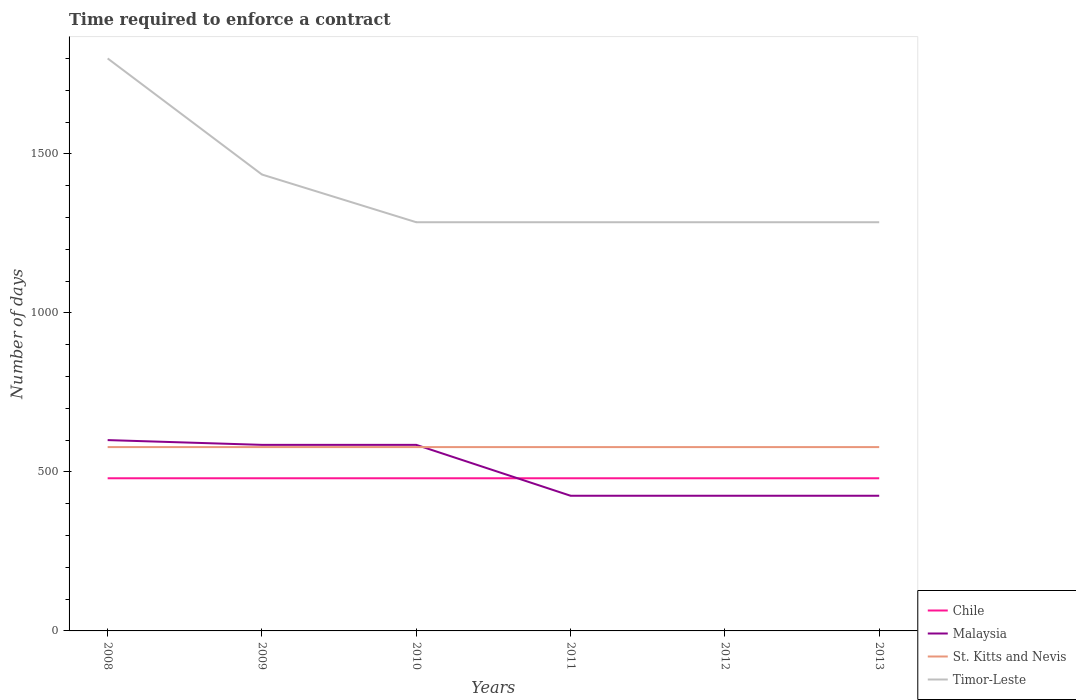How many different coloured lines are there?
Your response must be concise. 4. Does the line corresponding to Chile intersect with the line corresponding to Timor-Leste?
Offer a very short reply. No. Is the number of lines equal to the number of legend labels?
Make the answer very short. Yes. Across all years, what is the maximum number of days required to enforce a contract in Timor-Leste?
Provide a short and direct response. 1285. What is the difference between the highest and the second highest number of days required to enforce a contract in St. Kitts and Nevis?
Offer a very short reply. 0. Is the number of days required to enforce a contract in Malaysia strictly greater than the number of days required to enforce a contract in Timor-Leste over the years?
Provide a short and direct response. Yes. How many years are there in the graph?
Provide a short and direct response. 6. What is the difference between two consecutive major ticks on the Y-axis?
Make the answer very short. 500. Are the values on the major ticks of Y-axis written in scientific E-notation?
Your answer should be compact. No. Does the graph contain grids?
Your answer should be compact. No. How many legend labels are there?
Provide a succinct answer. 4. What is the title of the graph?
Your response must be concise. Time required to enforce a contract. What is the label or title of the Y-axis?
Give a very brief answer. Number of days. What is the Number of days of Chile in 2008?
Provide a short and direct response. 480. What is the Number of days in Malaysia in 2008?
Keep it short and to the point. 600. What is the Number of days in St. Kitts and Nevis in 2008?
Your answer should be very brief. 578. What is the Number of days of Timor-Leste in 2008?
Your response must be concise. 1800. What is the Number of days of Chile in 2009?
Make the answer very short. 480. What is the Number of days in Malaysia in 2009?
Keep it short and to the point. 585. What is the Number of days in St. Kitts and Nevis in 2009?
Make the answer very short. 578. What is the Number of days in Timor-Leste in 2009?
Your answer should be compact. 1435. What is the Number of days in Chile in 2010?
Offer a very short reply. 480. What is the Number of days in Malaysia in 2010?
Provide a succinct answer. 585. What is the Number of days of St. Kitts and Nevis in 2010?
Your answer should be very brief. 578. What is the Number of days in Timor-Leste in 2010?
Keep it short and to the point. 1285. What is the Number of days of Chile in 2011?
Provide a short and direct response. 480. What is the Number of days of Malaysia in 2011?
Ensure brevity in your answer.  425. What is the Number of days in St. Kitts and Nevis in 2011?
Keep it short and to the point. 578. What is the Number of days of Timor-Leste in 2011?
Provide a short and direct response. 1285. What is the Number of days of Chile in 2012?
Ensure brevity in your answer.  480. What is the Number of days in Malaysia in 2012?
Your answer should be very brief. 425. What is the Number of days of St. Kitts and Nevis in 2012?
Keep it short and to the point. 578. What is the Number of days in Timor-Leste in 2012?
Give a very brief answer. 1285. What is the Number of days of Chile in 2013?
Keep it short and to the point. 480. What is the Number of days of Malaysia in 2013?
Provide a succinct answer. 425. What is the Number of days in St. Kitts and Nevis in 2013?
Your answer should be compact. 578. What is the Number of days in Timor-Leste in 2013?
Offer a terse response. 1285. Across all years, what is the maximum Number of days in Chile?
Your response must be concise. 480. Across all years, what is the maximum Number of days of Malaysia?
Keep it short and to the point. 600. Across all years, what is the maximum Number of days in St. Kitts and Nevis?
Keep it short and to the point. 578. Across all years, what is the maximum Number of days in Timor-Leste?
Provide a succinct answer. 1800. Across all years, what is the minimum Number of days in Chile?
Offer a terse response. 480. Across all years, what is the minimum Number of days of Malaysia?
Ensure brevity in your answer.  425. Across all years, what is the minimum Number of days in St. Kitts and Nevis?
Your answer should be compact. 578. Across all years, what is the minimum Number of days in Timor-Leste?
Keep it short and to the point. 1285. What is the total Number of days in Chile in the graph?
Offer a terse response. 2880. What is the total Number of days of Malaysia in the graph?
Your answer should be compact. 3045. What is the total Number of days of St. Kitts and Nevis in the graph?
Offer a terse response. 3468. What is the total Number of days in Timor-Leste in the graph?
Make the answer very short. 8375. What is the difference between the Number of days in St. Kitts and Nevis in 2008 and that in 2009?
Offer a very short reply. 0. What is the difference between the Number of days in Timor-Leste in 2008 and that in 2009?
Keep it short and to the point. 365. What is the difference between the Number of days in Chile in 2008 and that in 2010?
Ensure brevity in your answer.  0. What is the difference between the Number of days in Timor-Leste in 2008 and that in 2010?
Provide a short and direct response. 515. What is the difference between the Number of days of Malaysia in 2008 and that in 2011?
Provide a short and direct response. 175. What is the difference between the Number of days of Timor-Leste in 2008 and that in 2011?
Make the answer very short. 515. What is the difference between the Number of days of Chile in 2008 and that in 2012?
Give a very brief answer. 0. What is the difference between the Number of days of Malaysia in 2008 and that in 2012?
Give a very brief answer. 175. What is the difference between the Number of days in St. Kitts and Nevis in 2008 and that in 2012?
Your answer should be very brief. 0. What is the difference between the Number of days in Timor-Leste in 2008 and that in 2012?
Offer a very short reply. 515. What is the difference between the Number of days of Chile in 2008 and that in 2013?
Ensure brevity in your answer.  0. What is the difference between the Number of days in Malaysia in 2008 and that in 2013?
Your response must be concise. 175. What is the difference between the Number of days of St. Kitts and Nevis in 2008 and that in 2013?
Provide a short and direct response. 0. What is the difference between the Number of days of Timor-Leste in 2008 and that in 2013?
Provide a short and direct response. 515. What is the difference between the Number of days in Malaysia in 2009 and that in 2010?
Your answer should be compact. 0. What is the difference between the Number of days in St. Kitts and Nevis in 2009 and that in 2010?
Make the answer very short. 0. What is the difference between the Number of days of Timor-Leste in 2009 and that in 2010?
Your answer should be compact. 150. What is the difference between the Number of days of Chile in 2009 and that in 2011?
Provide a succinct answer. 0. What is the difference between the Number of days in Malaysia in 2009 and that in 2011?
Make the answer very short. 160. What is the difference between the Number of days in Timor-Leste in 2009 and that in 2011?
Your answer should be very brief. 150. What is the difference between the Number of days in Chile in 2009 and that in 2012?
Offer a very short reply. 0. What is the difference between the Number of days in Malaysia in 2009 and that in 2012?
Make the answer very short. 160. What is the difference between the Number of days in St. Kitts and Nevis in 2009 and that in 2012?
Your answer should be very brief. 0. What is the difference between the Number of days in Timor-Leste in 2009 and that in 2012?
Make the answer very short. 150. What is the difference between the Number of days in Malaysia in 2009 and that in 2013?
Keep it short and to the point. 160. What is the difference between the Number of days in St. Kitts and Nevis in 2009 and that in 2013?
Your answer should be very brief. 0. What is the difference between the Number of days in Timor-Leste in 2009 and that in 2013?
Offer a very short reply. 150. What is the difference between the Number of days in Chile in 2010 and that in 2011?
Offer a terse response. 0. What is the difference between the Number of days of Malaysia in 2010 and that in 2011?
Provide a succinct answer. 160. What is the difference between the Number of days in St. Kitts and Nevis in 2010 and that in 2011?
Make the answer very short. 0. What is the difference between the Number of days in Malaysia in 2010 and that in 2012?
Your response must be concise. 160. What is the difference between the Number of days of Timor-Leste in 2010 and that in 2012?
Make the answer very short. 0. What is the difference between the Number of days of Chile in 2010 and that in 2013?
Ensure brevity in your answer.  0. What is the difference between the Number of days of Malaysia in 2010 and that in 2013?
Keep it short and to the point. 160. What is the difference between the Number of days in St. Kitts and Nevis in 2010 and that in 2013?
Provide a succinct answer. 0. What is the difference between the Number of days in Timor-Leste in 2010 and that in 2013?
Offer a very short reply. 0. What is the difference between the Number of days of Chile in 2011 and that in 2012?
Provide a short and direct response. 0. What is the difference between the Number of days of Chile in 2011 and that in 2013?
Give a very brief answer. 0. What is the difference between the Number of days of Malaysia in 2011 and that in 2013?
Provide a succinct answer. 0. What is the difference between the Number of days of Timor-Leste in 2011 and that in 2013?
Your response must be concise. 0. What is the difference between the Number of days in Chile in 2012 and that in 2013?
Provide a short and direct response. 0. What is the difference between the Number of days of Chile in 2008 and the Number of days of Malaysia in 2009?
Make the answer very short. -105. What is the difference between the Number of days in Chile in 2008 and the Number of days in St. Kitts and Nevis in 2009?
Make the answer very short. -98. What is the difference between the Number of days in Chile in 2008 and the Number of days in Timor-Leste in 2009?
Your response must be concise. -955. What is the difference between the Number of days in Malaysia in 2008 and the Number of days in St. Kitts and Nevis in 2009?
Keep it short and to the point. 22. What is the difference between the Number of days of Malaysia in 2008 and the Number of days of Timor-Leste in 2009?
Your response must be concise. -835. What is the difference between the Number of days in St. Kitts and Nevis in 2008 and the Number of days in Timor-Leste in 2009?
Your answer should be compact. -857. What is the difference between the Number of days of Chile in 2008 and the Number of days of Malaysia in 2010?
Provide a succinct answer. -105. What is the difference between the Number of days in Chile in 2008 and the Number of days in St. Kitts and Nevis in 2010?
Provide a short and direct response. -98. What is the difference between the Number of days in Chile in 2008 and the Number of days in Timor-Leste in 2010?
Provide a short and direct response. -805. What is the difference between the Number of days of Malaysia in 2008 and the Number of days of Timor-Leste in 2010?
Your answer should be compact. -685. What is the difference between the Number of days of St. Kitts and Nevis in 2008 and the Number of days of Timor-Leste in 2010?
Make the answer very short. -707. What is the difference between the Number of days in Chile in 2008 and the Number of days in Malaysia in 2011?
Keep it short and to the point. 55. What is the difference between the Number of days of Chile in 2008 and the Number of days of St. Kitts and Nevis in 2011?
Your answer should be compact. -98. What is the difference between the Number of days of Chile in 2008 and the Number of days of Timor-Leste in 2011?
Ensure brevity in your answer.  -805. What is the difference between the Number of days of Malaysia in 2008 and the Number of days of St. Kitts and Nevis in 2011?
Your answer should be compact. 22. What is the difference between the Number of days in Malaysia in 2008 and the Number of days in Timor-Leste in 2011?
Provide a short and direct response. -685. What is the difference between the Number of days in St. Kitts and Nevis in 2008 and the Number of days in Timor-Leste in 2011?
Your answer should be very brief. -707. What is the difference between the Number of days of Chile in 2008 and the Number of days of St. Kitts and Nevis in 2012?
Provide a succinct answer. -98. What is the difference between the Number of days in Chile in 2008 and the Number of days in Timor-Leste in 2012?
Make the answer very short. -805. What is the difference between the Number of days of Malaysia in 2008 and the Number of days of St. Kitts and Nevis in 2012?
Keep it short and to the point. 22. What is the difference between the Number of days in Malaysia in 2008 and the Number of days in Timor-Leste in 2012?
Keep it short and to the point. -685. What is the difference between the Number of days of St. Kitts and Nevis in 2008 and the Number of days of Timor-Leste in 2012?
Make the answer very short. -707. What is the difference between the Number of days of Chile in 2008 and the Number of days of St. Kitts and Nevis in 2013?
Provide a succinct answer. -98. What is the difference between the Number of days of Chile in 2008 and the Number of days of Timor-Leste in 2013?
Your answer should be compact. -805. What is the difference between the Number of days in Malaysia in 2008 and the Number of days in St. Kitts and Nevis in 2013?
Give a very brief answer. 22. What is the difference between the Number of days of Malaysia in 2008 and the Number of days of Timor-Leste in 2013?
Offer a very short reply. -685. What is the difference between the Number of days of St. Kitts and Nevis in 2008 and the Number of days of Timor-Leste in 2013?
Your answer should be very brief. -707. What is the difference between the Number of days in Chile in 2009 and the Number of days in Malaysia in 2010?
Make the answer very short. -105. What is the difference between the Number of days in Chile in 2009 and the Number of days in St. Kitts and Nevis in 2010?
Provide a short and direct response. -98. What is the difference between the Number of days of Chile in 2009 and the Number of days of Timor-Leste in 2010?
Make the answer very short. -805. What is the difference between the Number of days in Malaysia in 2009 and the Number of days in St. Kitts and Nevis in 2010?
Your answer should be very brief. 7. What is the difference between the Number of days in Malaysia in 2009 and the Number of days in Timor-Leste in 2010?
Keep it short and to the point. -700. What is the difference between the Number of days in St. Kitts and Nevis in 2009 and the Number of days in Timor-Leste in 2010?
Provide a succinct answer. -707. What is the difference between the Number of days of Chile in 2009 and the Number of days of St. Kitts and Nevis in 2011?
Give a very brief answer. -98. What is the difference between the Number of days in Chile in 2009 and the Number of days in Timor-Leste in 2011?
Offer a terse response. -805. What is the difference between the Number of days in Malaysia in 2009 and the Number of days in Timor-Leste in 2011?
Provide a succinct answer. -700. What is the difference between the Number of days of St. Kitts and Nevis in 2009 and the Number of days of Timor-Leste in 2011?
Make the answer very short. -707. What is the difference between the Number of days in Chile in 2009 and the Number of days in St. Kitts and Nevis in 2012?
Offer a terse response. -98. What is the difference between the Number of days in Chile in 2009 and the Number of days in Timor-Leste in 2012?
Your answer should be very brief. -805. What is the difference between the Number of days in Malaysia in 2009 and the Number of days in Timor-Leste in 2012?
Keep it short and to the point. -700. What is the difference between the Number of days of St. Kitts and Nevis in 2009 and the Number of days of Timor-Leste in 2012?
Your answer should be compact. -707. What is the difference between the Number of days of Chile in 2009 and the Number of days of St. Kitts and Nevis in 2013?
Keep it short and to the point. -98. What is the difference between the Number of days of Chile in 2009 and the Number of days of Timor-Leste in 2013?
Provide a short and direct response. -805. What is the difference between the Number of days of Malaysia in 2009 and the Number of days of Timor-Leste in 2013?
Offer a very short reply. -700. What is the difference between the Number of days in St. Kitts and Nevis in 2009 and the Number of days in Timor-Leste in 2013?
Your response must be concise. -707. What is the difference between the Number of days in Chile in 2010 and the Number of days in St. Kitts and Nevis in 2011?
Your answer should be very brief. -98. What is the difference between the Number of days of Chile in 2010 and the Number of days of Timor-Leste in 2011?
Give a very brief answer. -805. What is the difference between the Number of days in Malaysia in 2010 and the Number of days in Timor-Leste in 2011?
Make the answer very short. -700. What is the difference between the Number of days in St. Kitts and Nevis in 2010 and the Number of days in Timor-Leste in 2011?
Your response must be concise. -707. What is the difference between the Number of days of Chile in 2010 and the Number of days of St. Kitts and Nevis in 2012?
Your answer should be very brief. -98. What is the difference between the Number of days of Chile in 2010 and the Number of days of Timor-Leste in 2012?
Offer a very short reply. -805. What is the difference between the Number of days of Malaysia in 2010 and the Number of days of St. Kitts and Nevis in 2012?
Your answer should be very brief. 7. What is the difference between the Number of days of Malaysia in 2010 and the Number of days of Timor-Leste in 2012?
Your response must be concise. -700. What is the difference between the Number of days in St. Kitts and Nevis in 2010 and the Number of days in Timor-Leste in 2012?
Offer a terse response. -707. What is the difference between the Number of days of Chile in 2010 and the Number of days of St. Kitts and Nevis in 2013?
Keep it short and to the point. -98. What is the difference between the Number of days of Chile in 2010 and the Number of days of Timor-Leste in 2013?
Provide a succinct answer. -805. What is the difference between the Number of days of Malaysia in 2010 and the Number of days of St. Kitts and Nevis in 2013?
Offer a very short reply. 7. What is the difference between the Number of days in Malaysia in 2010 and the Number of days in Timor-Leste in 2013?
Keep it short and to the point. -700. What is the difference between the Number of days in St. Kitts and Nevis in 2010 and the Number of days in Timor-Leste in 2013?
Your response must be concise. -707. What is the difference between the Number of days in Chile in 2011 and the Number of days in Malaysia in 2012?
Give a very brief answer. 55. What is the difference between the Number of days in Chile in 2011 and the Number of days in St. Kitts and Nevis in 2012?
Provide a succinct answer. -98. What is the difference between the Number of days of Chile in 2011 and the Number of days of Timor-Leste in 2012?
Provide a short and direct response. -805. What is the difference between the Number of days of Malaysia in 2011 and the Number of days of St. Kitts and Nevis in 2012?
Your answer should be compact. -153. What is the difference between the Number of days of Malaysia in 2011 and the Number of days of Timor-Leste in 2012?
Provide a succinct answer. -860. What is the difference between the Number of days in St. Kitts and Nevis in 2011 and the Number of days in Timor-Leste in 2012?
Ensure brevity in your answer.  -707. What is the difference between the Number of days of Chile in 2011 and the Number of days of Malaysia in 2013?
Your answer should be very brief. 55. What is the difference between the Number of days in Chile in 2011 and the Number of days in St. Kitts and Nevis in 2013?
Ensure brevity in your answer.  -98. What is the difference between the Number of days of Chile in 2011 and the Number of days of Timor-Leste in 2013?
Your answer should be very brief. -805. What is the difference between the Number of days in Malaysia in 2011 and the Number of days in St. Kitts and Nevis in 2013?
Your response must be concise. -153. What is the difference between the Number of days of Malaysia in 2011 and the Number of days of Timor-Leste in 2013?
Provide a short and direct response. -860. What is the difference between the Number of days in St. Kitts and Nevis in 2011 and the Number of days in Timor-Leste in 2013?
Your response must be concise. -707. What is the difference between the Number of days in Chile in 2012 and the Number of days in Malaysia in 2013?
Your answer should be compact. 55. What is the difference between the Number of days of Chile in 2012 and the Number of days of St. Kitts and Nevis in 2013?
Give a very brief answer. -98. What is the difference between the Number of days of Chile in 2012 and the Number of days of Timor-Leste in 2013?
Ensure brevity in your answer.  -805. What is the difference between the Number of days of Malaysia in 2012 and the Number of days of St. Kitts and Nevis in 2013?
Offer a very short reply. -153. What is the difference between the Number of days in Malaysia in 2012 and the Number of days in Timor-Leste in 2013?
Your answer should be compact. -860. What is the difference between the Number of days in St. Kitts and Nevis in 2012 and the Number of days in Timor-Leste in 2013?
Offer a terse response. -707. What is the average Number of days in Chile per year?
Offer a terse response. 480. What is the average Number of days in Malaysia per year?
Make the answer very short. 507.5. What is the average Number of days of St. Kitts and Nevis per year?
Make the answer very short. 578. What is the average Number of days in Timor-Leste per year?
Your response must be concise. 1395.83. In the year 2008, what is the difference between the Number of days of Chile and Number of days of Malaysia?
Give a very brief answer. -120. In the year 2008, what is the difference between the Number of days in Chile and Number of days in St. Kitts and Nevis?
Provide a short and direct response. -98. In the year 2008, what is the difference between the Number of days of Chile and Number of days of Timor-Leste?
Offer a very short reply. -1320. In the year 2008, what is the difference between the Number of days in Malaysia and Number of days in St. Kitts and Nevis?
Offer a terse response. 22. In the year 2008, what is the difference between the Number of days in Malaysia and Number of days in Timor-Leste?
Provide a succinct answer. -1200. In the year 2008, what is the difference between the Number of days in St. Kitts and Nevis and Number of days in Timor-Leste?
Offer a terse response. -1222. In the year 2009, what is the difference between the Number of days of Chile and Number of days of Malaysia?
Your answer should be very brief. -105. In the year 2009, what is the difference between the Number of days in Chile and Number of days in St. Kitts and Nevis?
Provide a succinct answer. -98. In the year 2009, what is the difference between the Number of days in Chile and Number of days in Timor-Leste?
Give a very brief answer. -955. In the year 2009, what is the difference between the Number of days in Malaysia and Number of days in St. Kitts and Nevis?
Offer a terse response. 7. In the year 2009, what is the difference between the Number of days in Malaysia and Number of days in Timor-Leste?
Provide a succinct answer. -850. In the year 2009, what is the difference between the Number of days in St. Kitts and Nevis and Number of days in Timor-Leste?
Make the answer very short. -857. In the year 2010, what is the difference between the Number of days in Chile and Number of days in Malaysia?
Your answer should be very brief. -105. In the year 2010, what is the difference between the Number of days in Chile and Number of days in St. Kitts and Nevis?
Make the answer very short. -98. In the year 2010, what is the difference between the Number of days in Chile and Number of days in Timor-Leste?
Give a very brief answer. -805. In the year 2010, what is the difference between the Number of days of Malaysia and Number of days of St. Kitts and Nevis?
Ensure brevity in your answer.  7. In the year 2010, what is the difference between the Number of days of Malaysia and Number of days of Timor-Leste?
Ensure brevity in your answer.  -700. In the year 2010, what is the difference between the Number of days of St. Kitts and Nevis and Number of days of Timor-Leste?
Your answer should be compact. -707. In the year 2011, what is the difference between the Number of days of Chile and Number of days of St. Kitts and Nevis?
Offer a very short reply. -98. In the year 2011, what is the difference between the Number of days of Chile and Number of days of Timor-Leste?
Provide a short and direct response. -805. In the year 2011, what is the difference between the Number of days of Malaysia and Number of days of St. Kitts and Nevis?
Provide a succinct answer. -153. In the year 2011, what is the difference between the Number of days of Malaysia and Number of days of Timor-Leste?
Give a very brief answer. -860. In the year 2011, what is the difference between the Number of days of St. Kitts and Nevis and Number of days of Timor-Leste?
Give a very brief answer. -707. In the year 2012, what is the difference between the Number of days of Chile and Number of days of Malaysia?
Offer a very short reply. 55. In the year 2012, what is the difference between the Number of days of Chile and Number of days of St. Kitts and Nevis?
Your answer should be very brief. -98. In the year 2012, what is the difference between the Number of days in Chile and Number of days in Timor-Leste?
Offer a very short reply. -805. In the year 2012, what is the difference between the Number of days in Malaysia and Number of days in St. Kitts and Nevis?
Your answer should be compact. -153. In the year 2012, what is the difference between the Number of days in Malaysia and Number of days in Timor-Leste?
Make the answer very short. -860. In the year 2012, what is the difference between the Number of days in St. Kitts and Nevis and Number of days in Timor-Leste?
Keep it short and to the point. -707. In the year 2013, what is the difference between the Number of days of Chile and Number of days of St. Kitts and Nevis?
Make the answer very short. -98. In the year 2013, what is the difference between the Number of days in Chile and Number of days in Timor-Leste?
Make the answer very short. -805. In the year 2013, what is the difference between the Number of days in Malaysia and Number of days in St. Kitts and Nevis?
Keep it short and to the point. -153. In the year 2013, what is the difference between the Number of days of Malaysia and Number of days of Timor-Leste?
Your response must be concise. -860. In the year 2013, what is the difference between the Number of days of St. Kitts and Nevis and Number of days of Timor-Leste?
Make the answer very short. -707. What is the ratio of the Number of days in Chile in 2008 to that in 2009?
Your answer should be very brief. 1. What is the ratio of the Number of days in Malaysia in 2008 to that in 2009?
Your answer should be very brief. 1.03. What is the ratio of the Number of days in St. Kitts and Nevis in 2008 to that in 2009?
Ensure brevity in your answer.  1. What is the ratio of the Number of days in Timor-Leste in 2008 to that in 2009?
Provide a succinct answer. 1.25. What is the ratio of the Number of days in Chile in 2008 to that in 2010?
Keep it short and to the point. 1. What is the ratio of the Number of days of Malaysia in 2008 to that in 2010?
Provide a short and direct response. 1.03. What is the ratio of the Number of days in St. Kitts and Nevis in 2008 to that in 2010?
Your answer should be compact. 1. What is the ratio of the Number of days in Timor-Leste in 2008 to that in 2010?
Offer a very short reply. 1.4. What is the ratio of the Number of days in Chile in 2008 to that in 2011?
Your answer should be very brief. 1. What is the ratio of the Number of days of Malaysia in 2008 to that in 2011?
Offer a very short reply. 1.41. What is the ratio of the Number of days in Timor-Leste in 2008 to that in 2011?
Offer a terse response. 1.4. What is the ratio of the Number of days of Chile in 2008 to that in 2012?
Keep it short and to the point. 1. What is the ratio of the Number of days in Malaysia in 2008 to that in 2012?
Make the answer very short. 1.41. What is the ratio of the Number of days of Timor-Leste in 2008 to that in 2012?
Keep it short and to the point. 1.4. What is the ratio of the Number of days of Malaysia in 2008 to that in 2013?
Your response must be concise. 1.41. What is the ratio of the Number of days in Timor-Leste in 2008 to that in 2013?
Ensure brevity in your answer.  1.4. What is the ratio of the Number of days in Malaysia in 2009 to that in 2010?
Give a very brief answer. 1. What is the ratio of the Number of days in Timor-Leste in 2009 to that in 2010?
Your answer should be compact. 1.12. What is the ratio of the Number of days in Malaysia in 2009 to that in 2011?
Offer a terse response. 1.38. What is the ratio of the Number of days of Timor-Leste in 2009 to that in 2011?
Your response must be concise. 1.12. What is the ratio of the Number of days of Malaysia in 2009 to that in 2012?
Provide a short and direct response. 1.38. What is the ratio of the Number of days in Timor-Leste in 2009 to that in 2012?
Keep it short and to the point. 1.12. What is the ratio of the Number of days of Chile in 2009 to that in 2013?
Offer a terse response. 1. What is the ratio of the Number of days of Malaysia in 2009 to that in 2013?
Your answer should be compact. 1.38. What is the ratio of the Number of days in Timor-Leste in 2009 to that in 2013?
Provide a short and direct response. 1.12. What is the ratio of the Number of days of Chile in 2010 to that in 2011?
Your answer should be compact. 1. What is the ratio of the Number of days in Malaysia in 2010 to that in 2011?
Your response must be concise. 1.38. What is the ratio of the Number of days of Timor-Leste in 2010 to that in 2011?
Your answer should be compact. 1. What is the ratio of the Number of days in Chile in 2010 to that in 2012?
Give a very brief answer. 1. What is the ratio of the Number of days of Malaysia in 2010 to that in 2012?
Your answer should be very brief. 1.38. What is the ratio of the Number of days in St. Kitts and Nevis in 2010 to that in 2012?
Keep it short and to the point. 1. What is the ratio of the Number of days of Timor-Leste in 2010 to that in 2012?
Your response must be concise. 1. What is the ratio of the Number of days in Malaysia in 2010 to that in 2013?
Your answer should be compact. 1.38. What is the ratio of the Number of days of Timor-Leste in 2010 to that in 2013?
Your response must be concise. 1. What is the ratio of the Number of days in Malaysia in 2011 to that in 2012?
Offer a terse response. 1. What is the ratio of the Number of days of Chile in 2011 to that in 2013?
Your answer should be compact. 1. What is the ratio of the Number of days of St. Kitts and Nevis in 2011 to that in 2013?
Give a very brief answer. 1. What is the ratio of the Number of days of Chile in 2012 to that in 2013?
Offer a very short reply. 1. What is the difference between the highest and the second highest Number of days of Chile?
Offer a terse response. 0. What is the difference between the highest and the second highest Number of days of Malaysia?
Provide a succinct answer. 15. What is the difference between the highest and the second highest Number of days in Timor-Leste?
Offer a terse response. 365. What is the difference between the highest and the lowest Number of days in Chile?
Offer a very short reply. 0. What is the difference between the highest and the lowest Number of days in Malaysia?
Your answer should be compact. 175. What is the difference between the highest and the lowest Number of days in St. Kitts and Nevis?
Offer a very short reply. 0. What is the difference between the highest and the lowest Number of days in Timor-Leste?
Offer a very short reply. 515. 